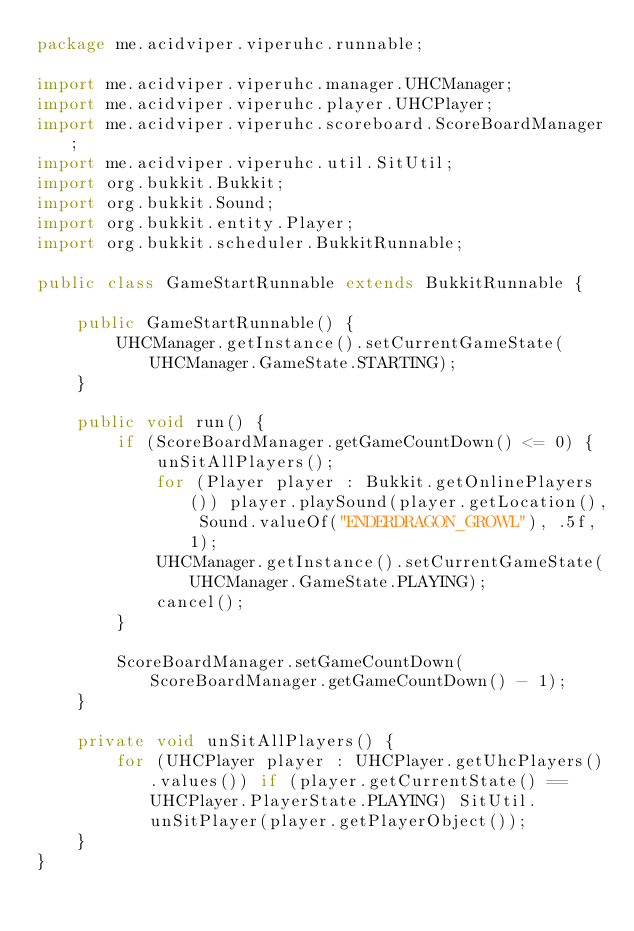Convert code to text. <code><loc_0><loc_0><loc_500><loc_500><_Java_>package me.acidviper.viperuhc.runnable;

import me.acidviper.viperuhc.manager.UHCManager;
import me.acidviper.viperuhc.player.UHCPlayer;
import me.acidviper.viperuhc.scoreboard.ScoreBoardManager;
import me.acidviper.viperuhc.util.SitUtil;
import org.bukkit.Bukkit;
import org.bukkit.Sound;
import org.bukkit.entity.Player;
import org.bukkit.scheduler.BukkitRunnable;

public class GameStartRunnable extends BukkitRunnable {

    public GameStartRunnable() {
        UHCManager.getInstance().setCurrentGameState(UHCManager.GameState.STARTING);
    }

    public void run() {
        if (ScoreBoardManager.getGameCountDown() <= 0) {
            unSitAllPlayers();
            for (Player player : Bukkit.getOnlinePlayers()) player.playSound(player.getLocation(), Sound.valueOf("ENDERDRAGON_GROWL"), .5f, 1);
            UHCManager.getInstance().setCurrentGameState(UHCManager.GameState.PLAYING);
            cancel();
        }

        ScoreBoardManager.setGameCountDown(ScoreBoardManager.getGameCountDown() - 1);
    }

    private void unSitAllPlayers() {
        for (UHCPlayer player : UHCPlayer.getUhcPlayers().values()) if (player.getCurrentState() == UHCPlayer.PlayerState.PLAYING) SitUtil.unSitPlayer(player.getPlayerObject());
    }
}
</code> 